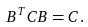<formula> <loc_0><loc_0><loc_500><loc_500>B ^ { T } C B = C .</formula> 